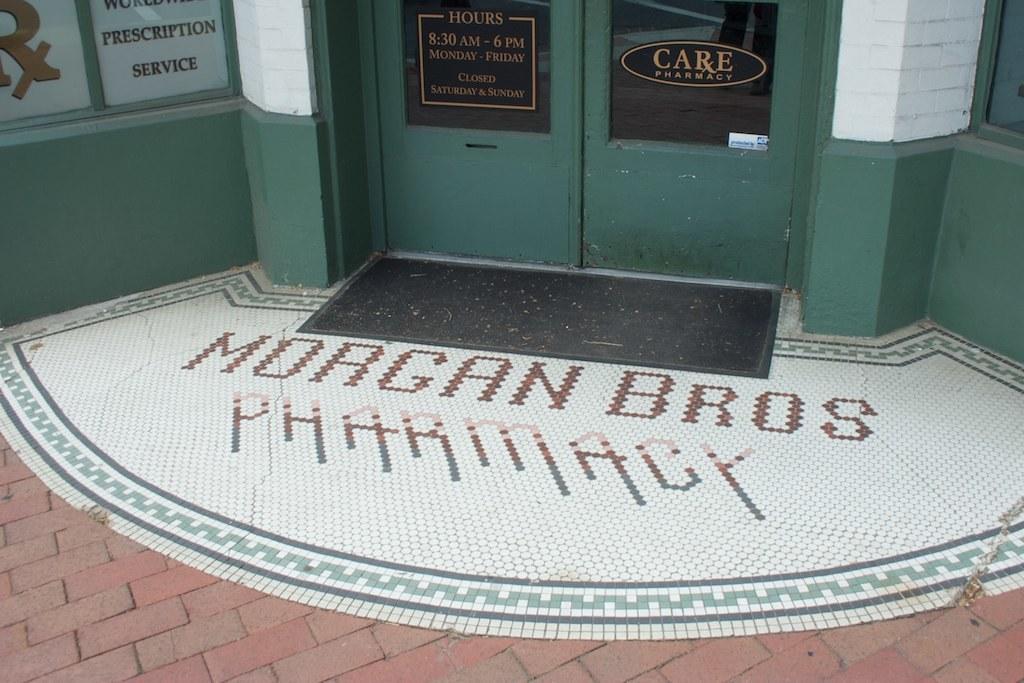In one or two sentences, can you explain what this image depicts? In this image I can see something is written in the center and in the background I can see few green colour doors and on it I can see something is written. On the left top corner of this image I can see few boards and on these words I can see something is written. 